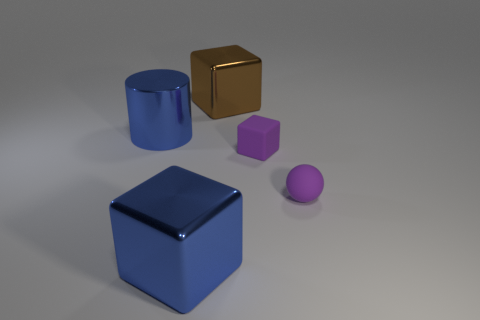What number of blue metallic spheres have the same size as the purple block?
Provide a succinct answer. 0. What is the size of the object that is the same color as the cylinder?
Ensure brevity in your answer.  Large. Is there a matte block that has the same color as the large metallic cylinder?
Your response must be concise. No. The rubber ball that is the same size as the purple matte block is what color?
Provide a succinct answer. Purple. There is a tiny rubber cube; is it the same color as the tiny object in front of the rubber block?
Make the answer very short. Yes. What is the color of the small rubber sphere?
Offer a very short reply. Purple. There is a big blue thing in front of the purple cube; what is it made of?
Ensure brevity in your answer.  Metal. There is a blue metallic object that is the same shape as the large brown metal thing; what size is it?
Your answer should be compact. Large. Are there fewer large blue shiny cubes that are to the right of the brown shiny cube than tiny green shiny cylinders?
Give a very brief answer. No. Are there any green metallic objects?
Offer a terse response. No. 